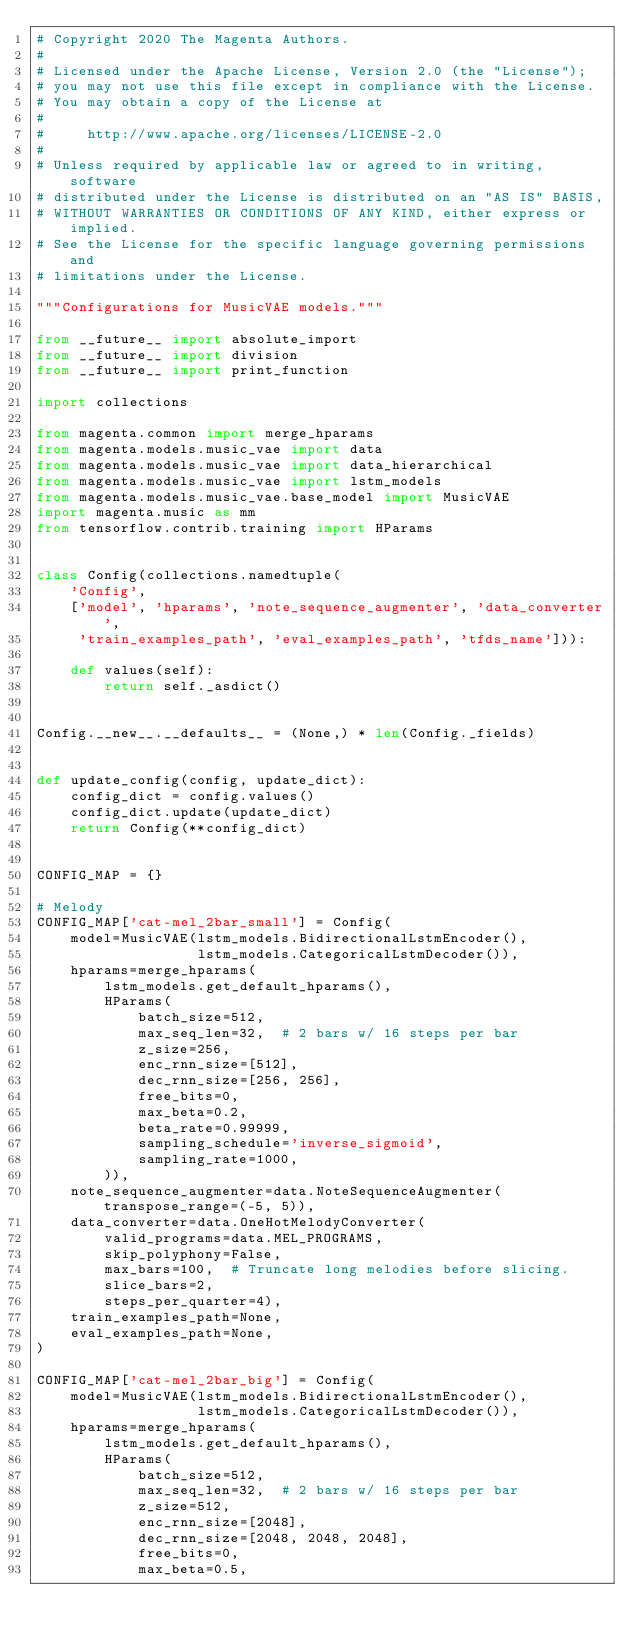Convert code to text. <code><loc_0><loc_0><loc_500><loc_500><_Python_># Copyright 2020 The Magenta Authors.
#
# Licensed under the Apache License, Version 2.0 (the "License");
# you may not use this file except in compliance with the License.
# You may obtain a copy of the License at
#
#     http://www.apache.org/licenses/LICENSE-2.0
#
# Unless required by applicable law or agreed to in writing, software
# distributed under the License is distributed on an "AS IS" BASIS,
# WITHOUT WARRANTIES OR CONDITIONS OF ANY KIND, either express or implied.
# See the License for the specific language governing permissions and
# limitations under the License.

"""Configurations for MusicVAE models."""

from __future__ import absolute_import
from __future__ import division
from __future__ import print_function

import collections

from magenta.common import merge_hparams
from magenta.models.music_vae import data
from magenta.models.music_vae import data_hierarchical
from magenta.models.music_vae import lstm_models
from magenta.models.music_vae.base_model import MusicVAE
import magenta.music as mm
from tensorflow.contrib.training import HParams


class Config(collections.namedtuple(
    'Config',
    ['model', 'hparams', 'note_sequence_augmenter', 'data_converter',
     'train_examples_path', 'eval_examples_path', 'tfds_name'])):

    def values(self):
        return self._asdict()


Config.__new__.__defaults__ = (None,) * len(Config._fields)


def update_config(config, update_dict):
    config_dict = config.values()
    config_dict.update(update_dict)
    return Config(**config_dict)


CONFIG_MAP = {}

# Melody
CONFIG_MAP['cat-mel_2bar_small'] = Config(
    model=MusicVAE(lstm_models.BidirectionalLstmEncoder(),
                   lstm_models.CategoricalLstmDecoder()),
    hparams=merge_hparams(
        lstm_models.get_default_hparams(),
        HParams(
            batch_size=512,
            max_seq_len=32,  # 2 bars w/ 16 steps per bar
            z_size=256,
            enc_rnn_size=[512],
            dec_rnn_size=[256, 256],
            free_bits=0,
            max_beta=0.2,
            beta_rate=0.99999,
            sampling_schedule='inverse_sigmoid',
            sampling_rate=1000,
        )),
    note_sequence_augmenter=data.NoteSequenceAugmenter(transpose_range=(-5, 5)),
    data_converter=data.OneHotMelodyConverter(
        valid_programs=data.MEL_PROGRAMS,
        skip_polyphony=False,
        max_bars=100,  # Truncate long melodies before slicing.
        slice_bars=2,
        steps_per_quarter=4),
    train_examples_path=None,
    eval_examples_path=None,
)

CONFIG_MAP['cat-mel_2bar_big'] = Config(
    model=MusicVAE(lstm_models.BidirectionalLstmEncoder(),
                   lstm_models.CategoricalLstmDecoder()),
    hparams=merge_hparams(
        lstm_models.get_default_hparams(),
        HParams(
            batch_size=512,
            max_seq_len=32,  # 2 bars w/ 16 steps per bar
            z_size=512,
            enc_rnn_size=[2048],
            dec_rnn_size=[2048, 2048, 2048],
            free_bits=0,
            max_beta=0.5,</code> 